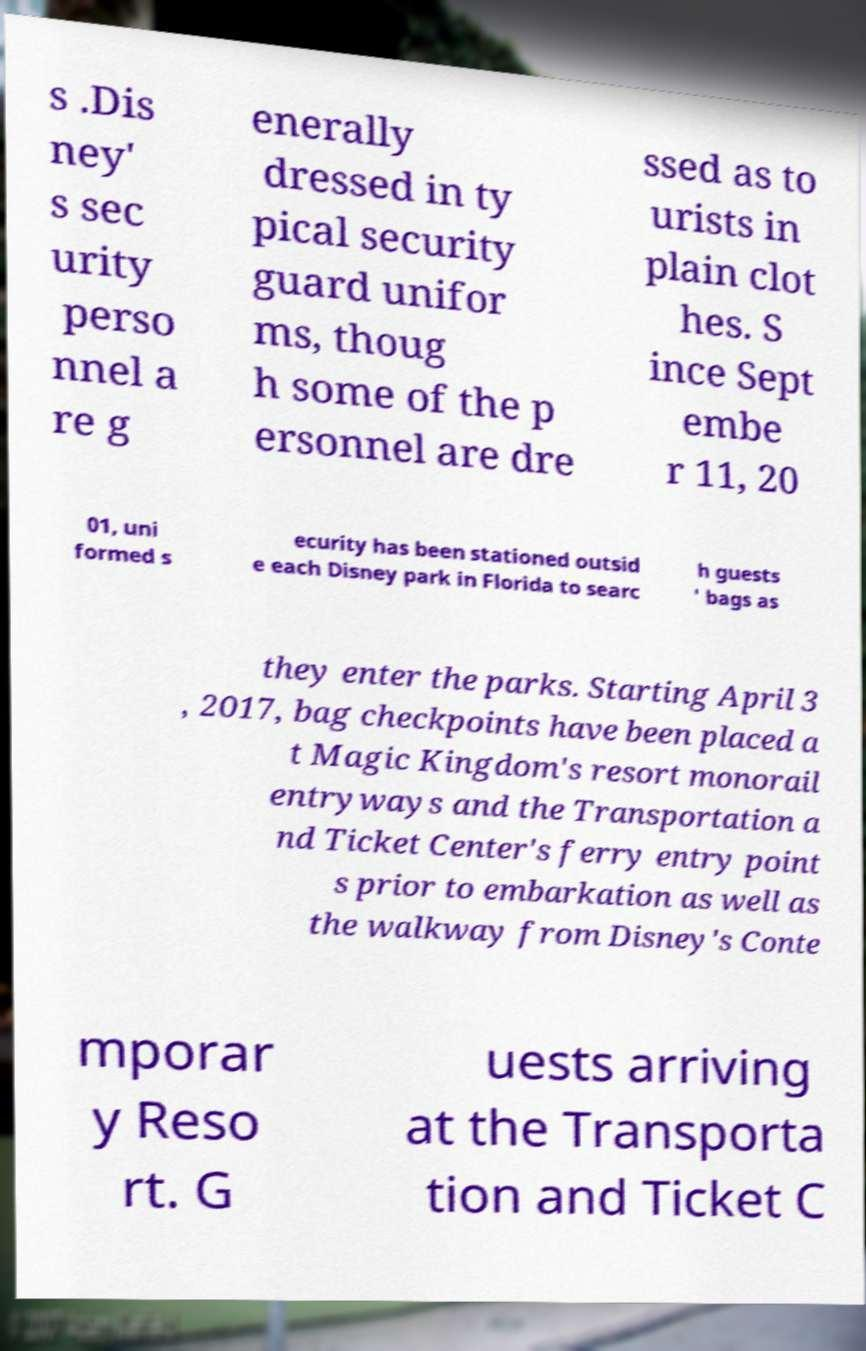Please read and relay the text visible in this image. What does it say? s .Dis ney' s sec urity perso nnel a re g enerally dressed in ty pical security guard unifor ms, thoug h some of the p ersonnel are dre ssed as to urists in plain clot hes. S ince Sept embe r 11, 20 01, uni formed s ecurity has been stationed outsid e each Disney park in Florida to searc h guests ' bags as they enter the parks. Starting April 3 , 2017, bag checkpoints have been placed a t Magic Kingdom's resort monorail entryways and the Transportation a nd Ticket Center's ferry entry point s prior to embarkation as well as the walkway from Disney's Conte mporar y Reso rt. G uests arriving at the Transporta tion and Ticket C 